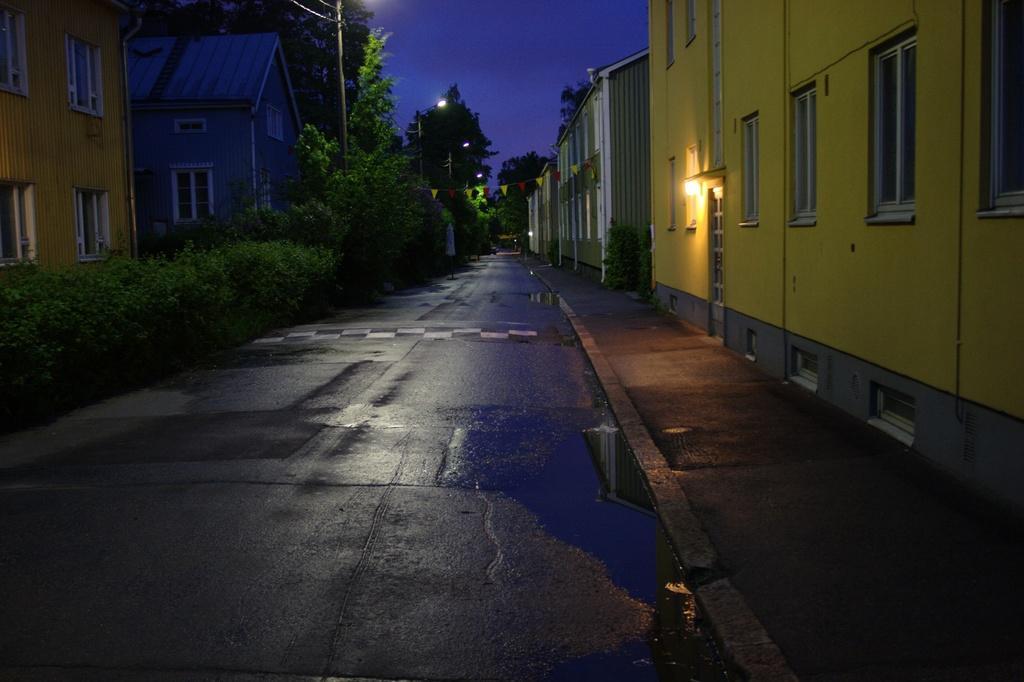How would you summarize this image in a sentence or two? In this image, I can see the buildings with the windows and doors. This looks like a lamp. I can see the road. These are the trees and bushes, which are beside the road. I think these are the street lights. At the top of the image, I can see the sky. 